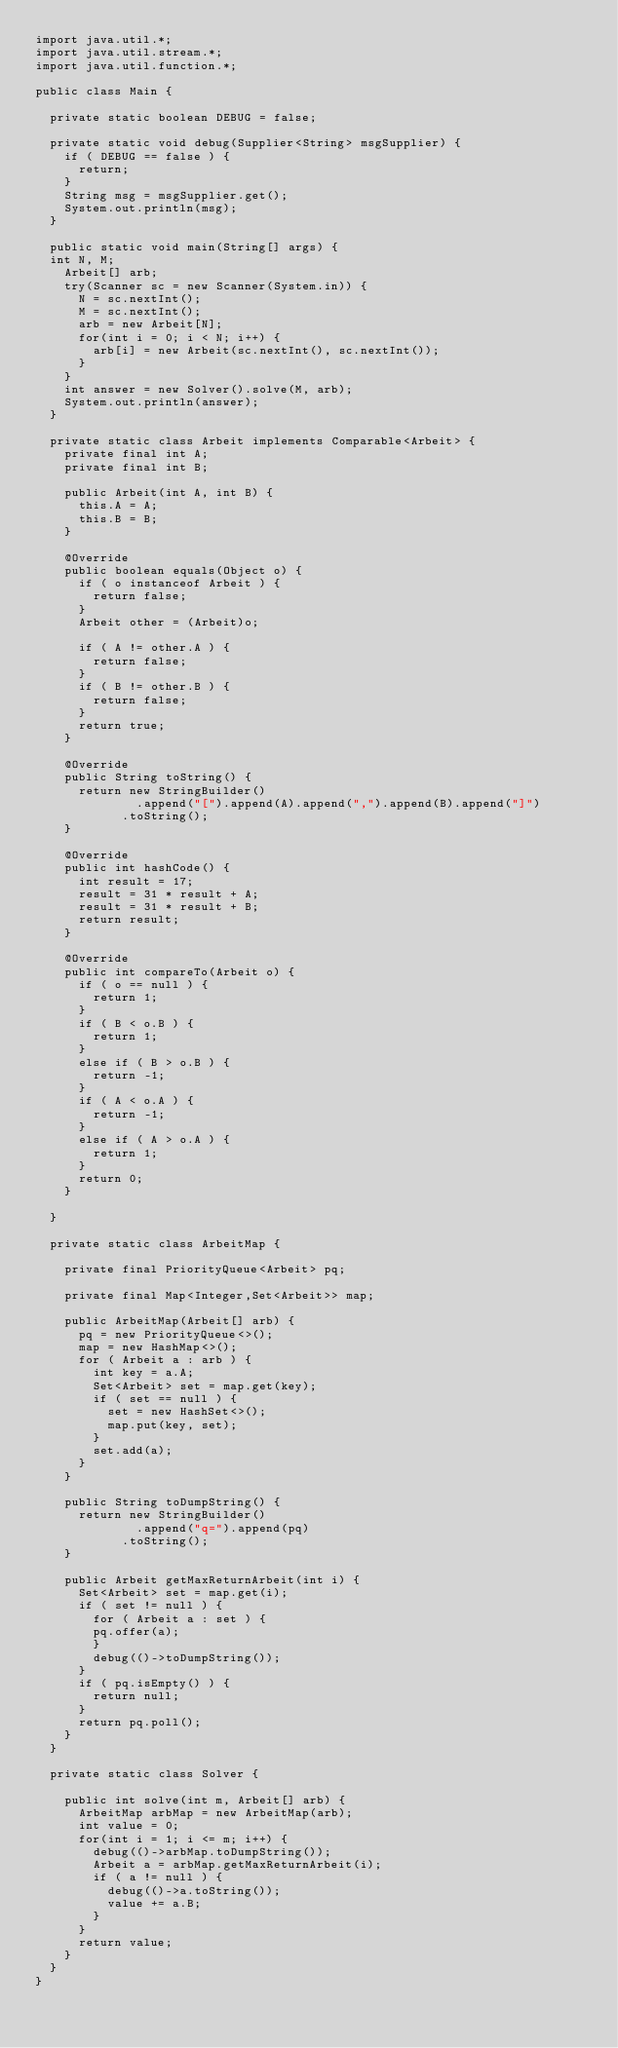<code> <loc_0><loc_0><loc_500><loc_500><_Java_>import java.util.*;
import java.util.stream.*;
import java.util.function.*;

public class Main {
  
  private static boolean DEBUG = false;
  
  private static void debug(Supplier<String> msgSupplier) {
    if ( DEBUG == false ) {
      return;
    }
    String msg = msgSupplier.get();
    System.out.println(msg);
  }
  
  public static void main(String[] args) {
	int N, M;
    Arbeit[] arb;
    try(Scanner sc = new Scanner(System.in)) {
      N = sc.nextInt();
      M = sc.nextInt();
      arb = new Arbeit[N];
      for(int i = 0; i < N; i++) {
        arb[i] = new Arbeit(sc.nextInt(), sc.nextInt());
      }
    }
    int answer = new Solver().solve(M, arb);
    System.out.println(answer);
  }
  
  private static class Arbeit implements Comparable<Arbeit> {
    private final int A;
    private final int B;
    
    public Arbeit(int A, int B) {
      this.A = A;
      this.B = B;
    }
    
    @Override
    public boolean equals(Object o) {
      if ( o instanceof Arbeit ) {
        return false;
      }
      Arbeit other = (Arbeit)o;
      
      if ( A != other.A ) {
        return false;
      }
      if ( B != other.B ) {
        return false;
      }
      return true;
    }
    
    @Override
    public String toString() {
      return new StringBuilder()
        			.append("[").append(A).append(",").append(B).append("]")
        		.toString();
    }
    
    @Override
    public int hashCode() {
      int result = 17;
      result = 31 * result + A;
      result = 31 * result + B;
      return result;
    }
    
    @Override
    public int compareTo(Arbeit o) {
      if ( o == null ) {
        return 1;
      }
      if ( B < o.B ) {
        return 1;
      }
      else if ( B > o.B ) {
        return -1;
      }
      if ( A < o.A ) {
        return -1;
      }
      else if ( A > o.A ) {
        return 1;
      }
      return 0;
    }
    
  }
  
  private static class ArbeitMap {
    
    private final PriorityQueue<Arbeit> pq;
    
    private final Map<Integer,Set<Arbeit>> map;
    
    public ArbeitMap(Arbeit[] arb) {
      pq = new PriorityQueue<>();
      map = new HashMap<>();
      for ( Arbeit a : arb ) {
        int key = a.A;
        Set<Arbeit> set = map.get(key);
        if ( set == null ) {
          set = new HashSet<>();
          map.put(key, set);
        }
        set.add(a);
      }
    }
    
    public String toDumpString() {
      return new StringBuilder()
        			.append("q=").append(pq)
        		.toString();
    }
    
    public Arbeit getMaxReturnArbeit(int i) {
      Set<Arbeit> set = map.get(i);
      if ( set != null ) {
        for ( Arbeit a : set ) {
	      pq.offer(a);
        }
        debug(()->toDumpString());
      }
      if ( pq.isEmpty() ) {
        return null;
      }
      return pq.poll();
    }
  }

  private static class Solver {
    
    public int solve(int m, Arbeit[] arb) {
      ArbeitMap arbMap = new ArbeitMap(arb);
      int value = 0;
      for(int i = 1; i <= m; i++) {
        debug(()->arbMap.toDumpString());
        Arbeit a = arbMap.getMaxReturnArbeit(i);
        if ( a != null ) {
          debug(()->a.toString());
          value += a.B;
        }
      }
      return value;
    }
  }
}</code> 